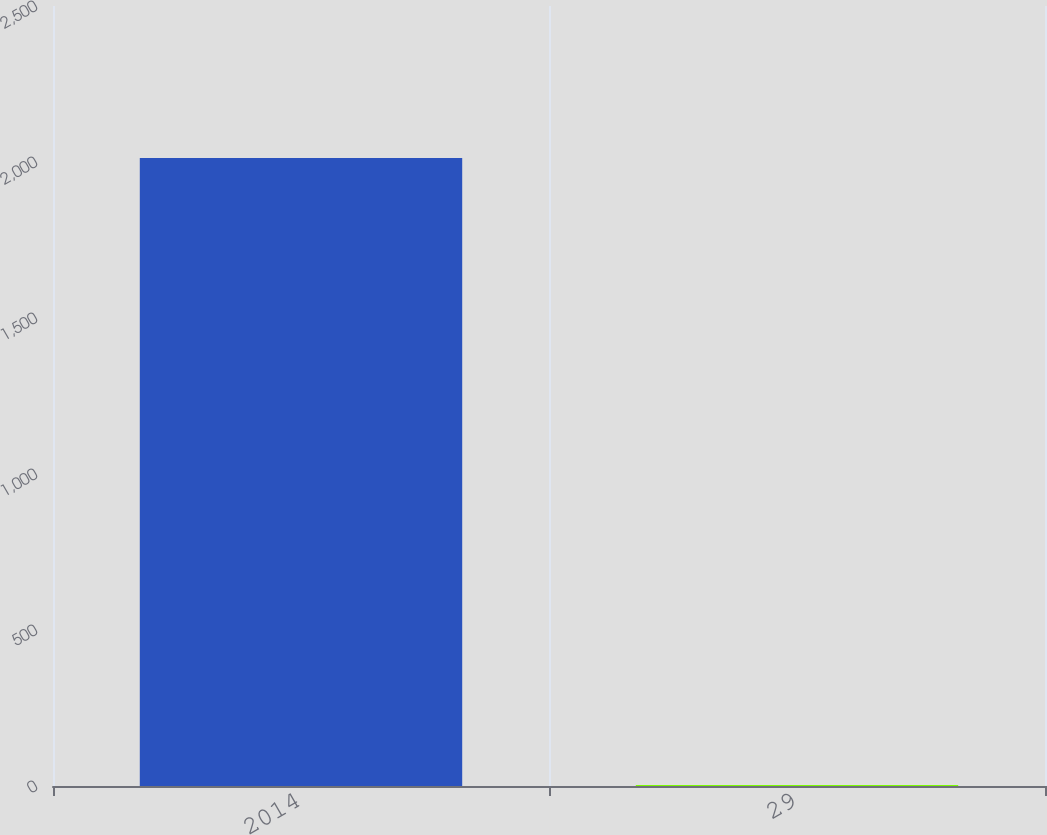Convert chart to OTSL. <chart><loc_0><loc_0><loc_500><loc_500><bar_chart><fcel>2014<fcel>29<nl><fcel>2013<fcel>3.2<nl></chart> 